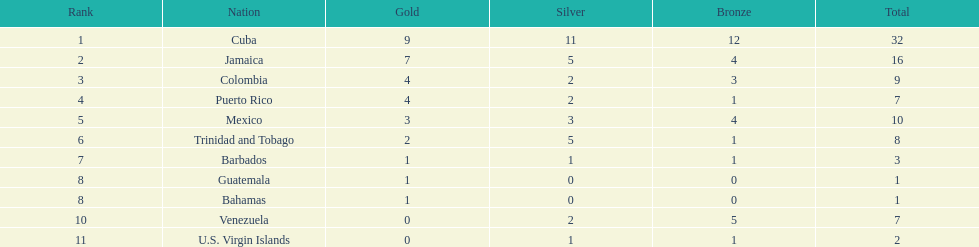In the games, which nations were the competitors? Cuba, Jamaica, Colombia, Puerto Rico, Mexico, Trinidad and Tobago, Barbados, Guatemala, Bahamas, Venezuela, U.S. Virgin Islands. What was the count of silver medals they achieved? 11, 5, 2, 2, 3, 5, 1, 0, 0, 2, 1. Which team emerged with the greatest number of silver wins? Cuba. 